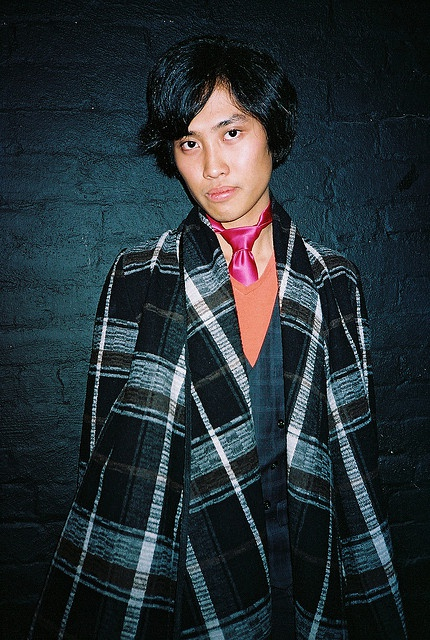Describe the objects in this image and their specific colors. I can see people in black, blue, and gray tones and tie in black, brown, and violet tones in this image. 